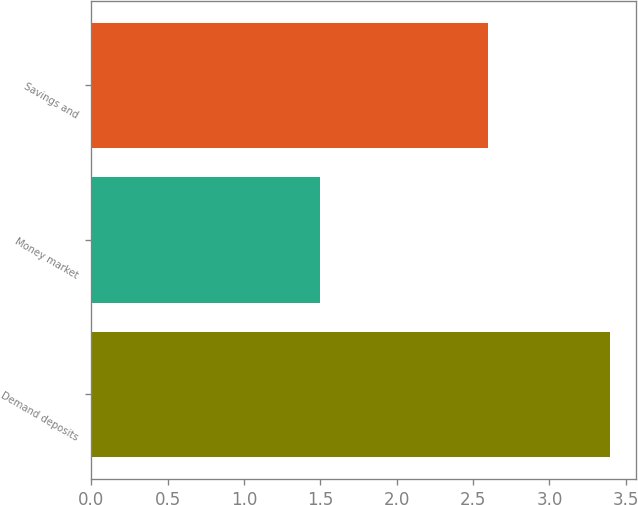<chart> <loc_0><loc_0><loc_500><loc_500><bar_chart><fcel>Demand deposits<fcel>Money market<fcel>Savings and<nl><fcel>3.4<fcel>1.5<fcel>2.6<nl></chart> 